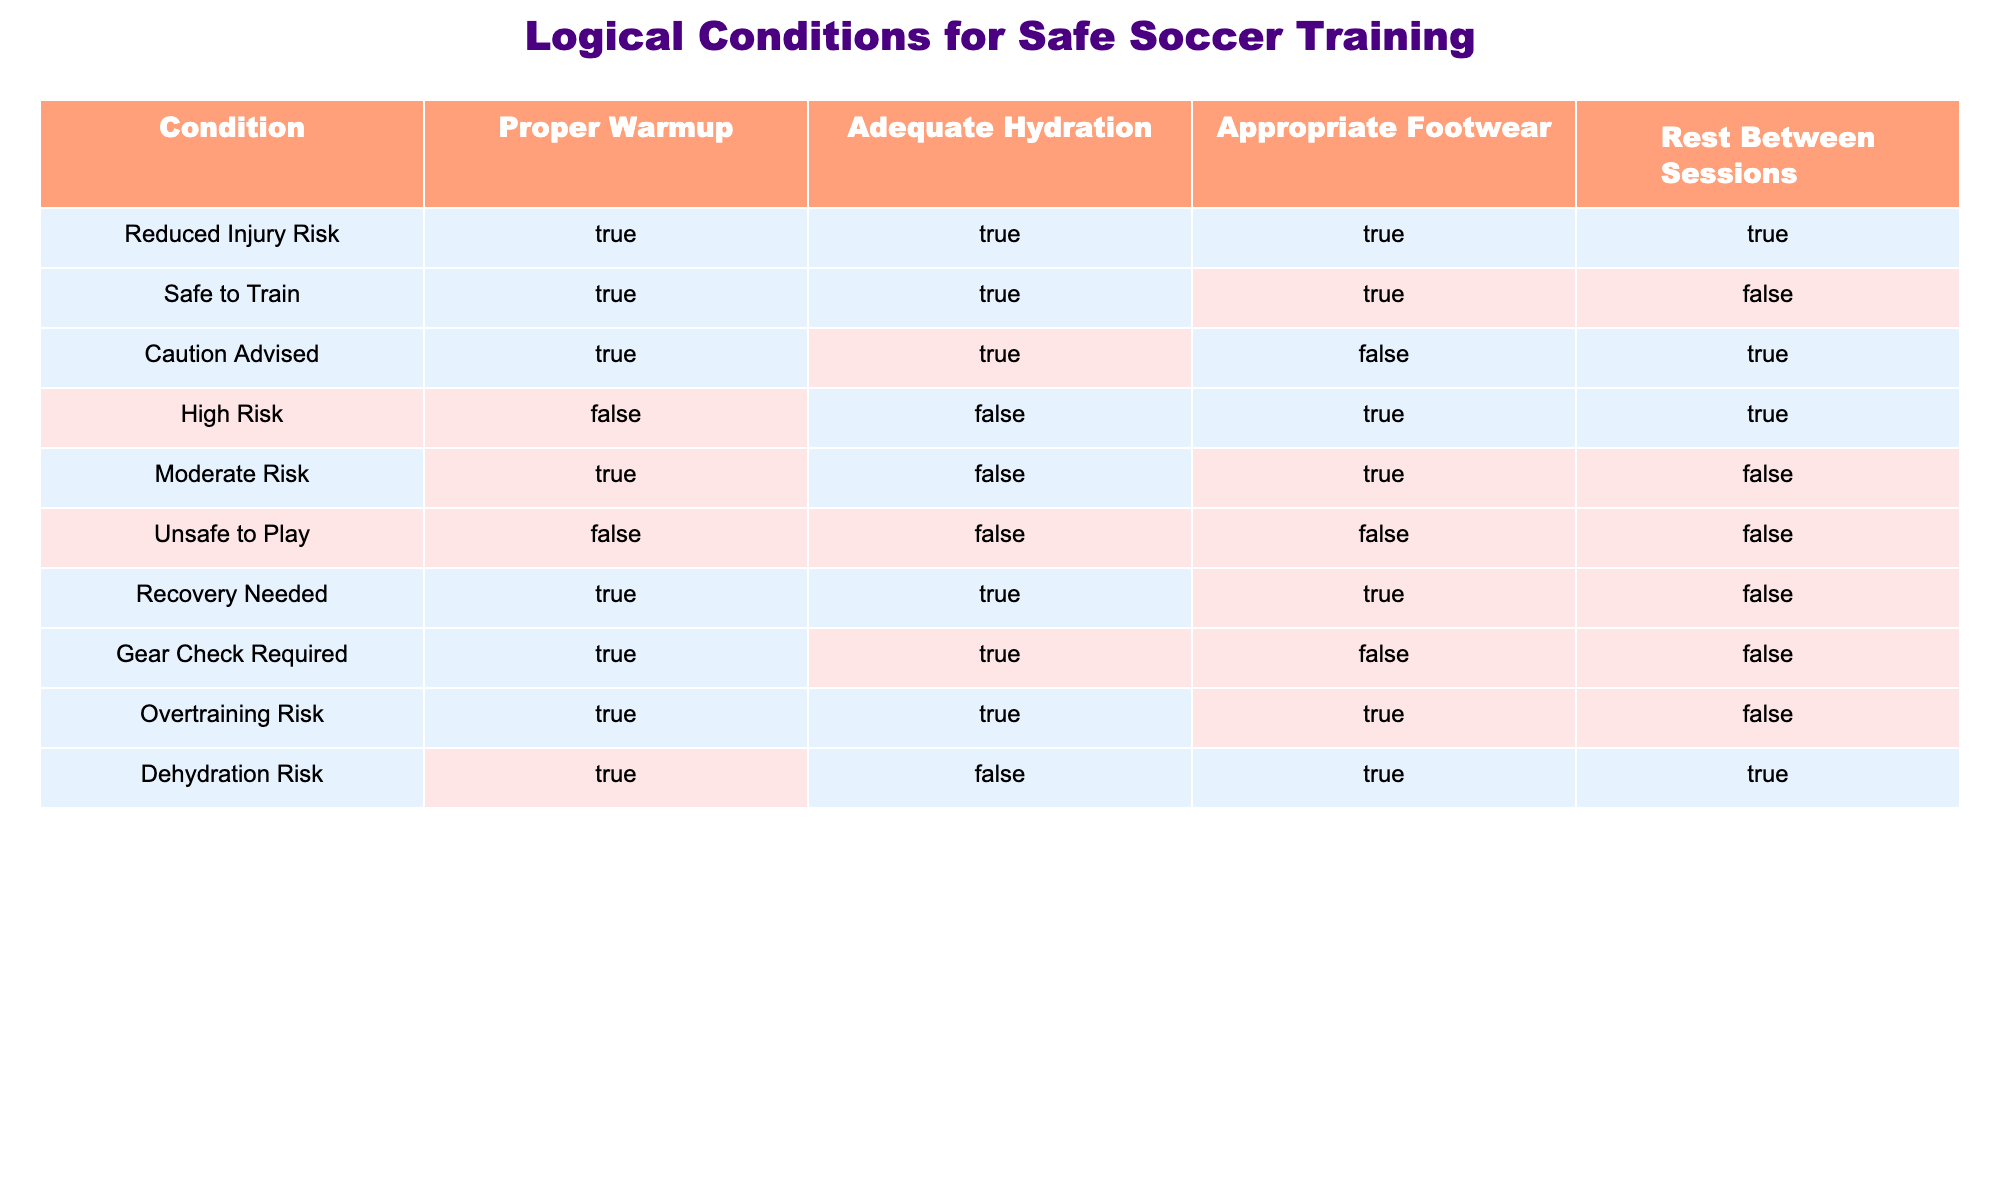What condition applies if there is no proper warmup or adequate hydration? According to the table, if both proper warmup and adequate hydration are false, the condition falls under "Unsafe to Play". This is confirmed by checking the row where both 'Proper Warmup' and 'Adequate Hydration' are marked as false, leading to the conclusion.
Answer: Unsafe to Play Which scenario requires a gear check? From the table, the scenario labeled "Gear Check Required" is where there is proper warmup, adequate hydration, and improper footwear (false). This conclusion is drawn by locating the row that specifically highlights "Gear Check Required" and observing the respective conditions.
Answer: Gear Check Required Is training safe if proper warmup and adequate hydration are both true? Yes, according to the table, when both 'Proper Warmup' and 'Adequate Hydration' are true, the condition is either "Reduced Injury Risk" or "Safe to Train" (four rows fulfill these criteria). Thus, it confirms a safe training environment.
Answer: Yes What percentage of conditions require proper footwear for reduced risk? From the table, "Reduced Injury Risk", "Caution Advised", "Overtraining Risk", and "Dehydration Risk" all require proper footwear. Therefore, out of the total 10 conditions, there are 5 that require proper footwear, which gives a percentage of (5/10)*100 = 50%.
Answer: 50% What is the relationship between adequate hydration and recovery needed? The table shows that both conditions of "Recovery Needed" and "Adequate Hydration" are true. This implies that adequate hydration is crucial for recovery as indicated in the row for "Recovery Needed" where hydration is marked as true.
Answer: They are directly related 